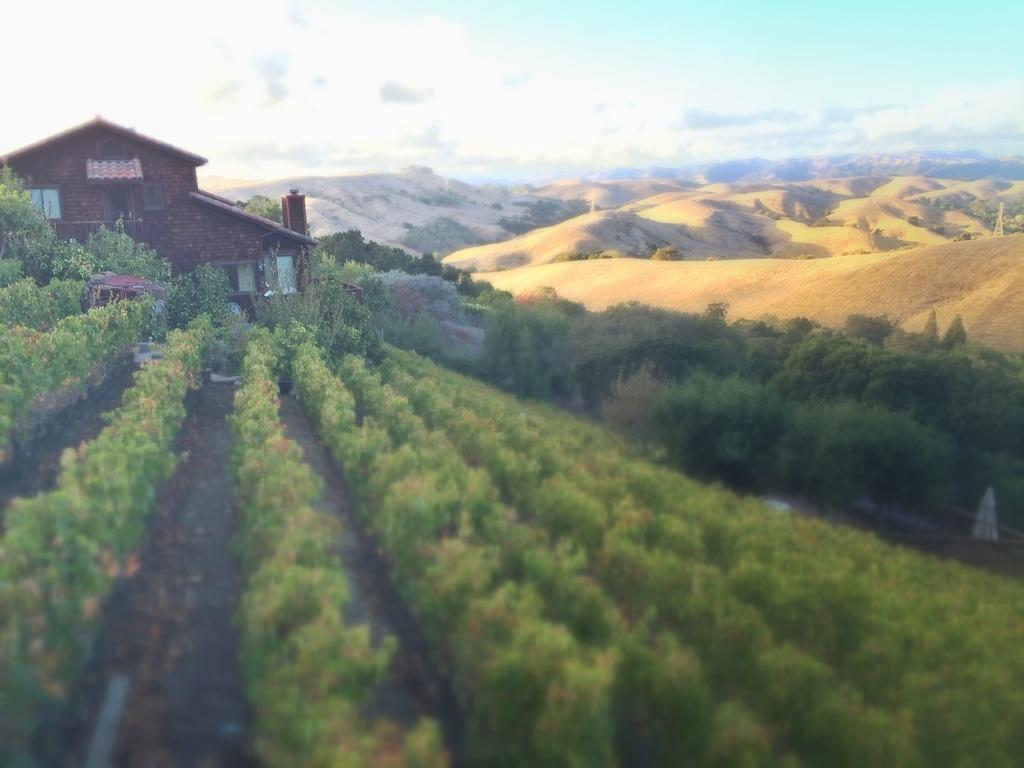What type of vegetation can be seen in the image? There are plants and trees in the image. What type of structure is visible in the image? There is a house in the image. What type of landscape feature is present in the image? There are hills in the image. What is visible in the background of the image? The sky is visible in the background of the image. Where is the writer sitting during the party in the image? There is no writer or party present in the image. What type of match is being played on the hills in the image? There is no match being played in the image; it features plants, trees, a house, hills, and the sky. 